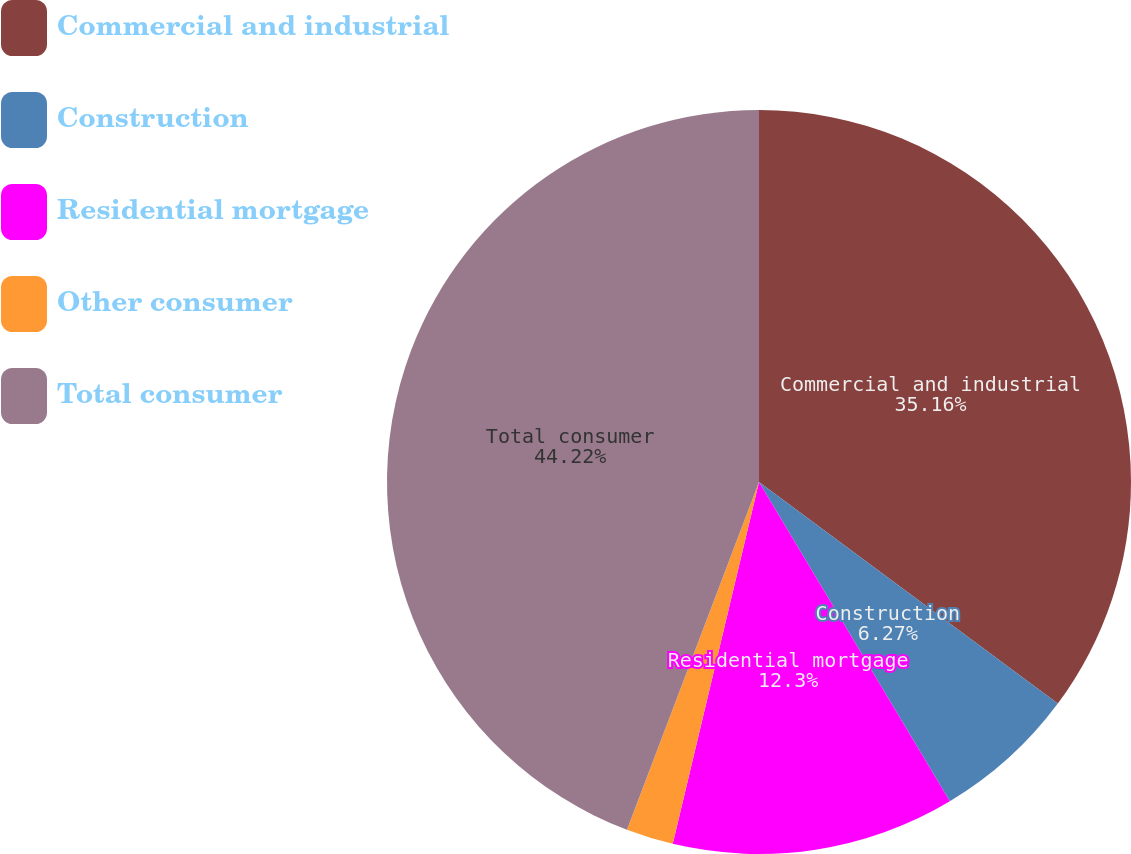<chart> <loc_0><loc_0><loc_500><loc_500><pie_chart><fcel>Commercial and industrial<fcel>Construction<fcel>Residential mortgage<fcel>Other consumer<fcel>Total consumer<nl><fcel>35.16%<fcel>6.27%<fcel>12.3%<fcel>2.05%<fcel>44.23%<nl></chart> 